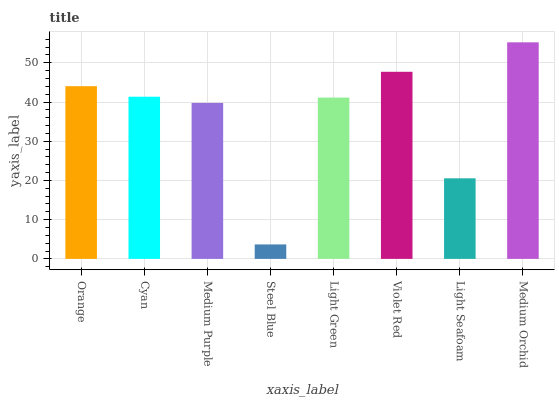Is Steel Blue the minimum?
Answer yes or no. Yes. Is Medium Orchid the maximum?
Answer yes or no. Yes. Is Cyan the minimum?
Answer yes or no. No. Is Cyan the maximum?
Answer yes or no. No. Is Orange greater than Cyan?
Answer yes or no. Yes. Is Cyan less than Orange?
Answer yes or no. Yes. Is Cyan greater than Orange?
Answer yes or no. No. Is Orange less than Cyan?
Answer yes or no. No. Is Cyan the high median?
Answer yes or no. Yes. Is Light Green the low median?
Answer yes or no. Yes. Is Violet Red the high median?
Answer yes or no. No. Is Violet Red the low median?
Answer yes or no. No. 